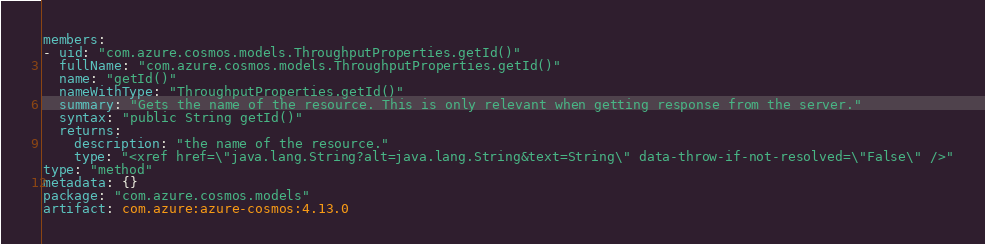Convert code to text. <code><loc_0><loc_0><loc_500><loc_500><_YAML_>members:
- uid: "com.azure.cosmos.models.ThroughputProperties.getId()"
  fullName: "com.azure.cosmos.models.ThroughputProperties.getId()"
  name: "getId()"
  nameWithType: "ThroughputProperties.getId()"
  summary: "Gets the name of the resource. This is only relevant when getting response from the server."
  syntax: "public String getId()"
  returns:
    description: "the name of the resource."
    type: "<xref href=\"java.lang.String?alt=java.lang.String&text=String\" data-throw-if-not-resolved=\"False\" />"
type: "method"
metadata: {}
package: "com.azure.cosmos.models"
artifact: com.azure:azure-cosmos:4.13.0
</code> 